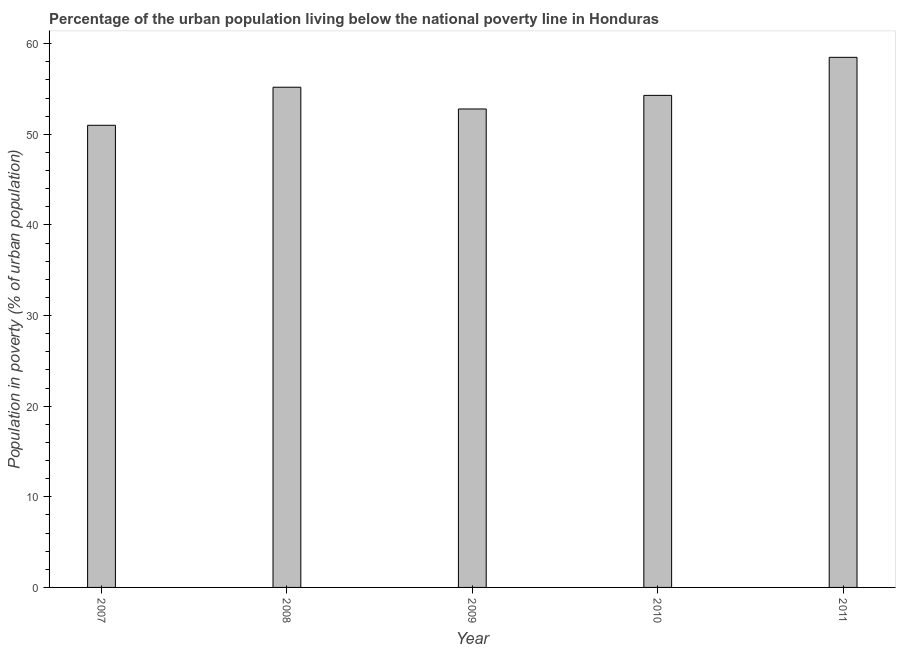Does the graph contain grids?
Ensure brevity in your answer.  No. What is the title of the graph?
Offer a terse response. Percentage of the urban population living below the national poverty line in Honduras. What is the label or title of the X-axis?
Your answer should be compact. Year. What is the label or title of the Y-axis?
Provide a short and direct response. Population in poverty (% of urban population). What is the percentage of urban population living below poverty line in 2007?
Keep it short and to the point. 51. Across all years, what is the maximum percentage of urban population living below poverty line?
Your response must be concise. 58.5. Across all years, what is the minimum percentage of urban population living below poverty line?
Keep it short and to the point. 51. What is the sum of the percentage of urban population living below poverty line?
Give a very brief answer. 271.8. What is the difference between the percentage of urban population living below poverty line in 2007 and 2010?
Your answer should be compact. -3.3. What is the average percentage of urban population living below poverty line per year?
Provide a succinct answer. 54.36. What is the median percentage of urban population living below poverty line?
Provide a succinct answer. 54.3. Do a majority of the years between 2008 and 2009 (inclusive) have percentage of urban population living below poverty line greater than 12 %?
Keep it short and to the point. Yes. What is the ratio of the percentage of urban population living below poverty line in 2010 to that in 2011?
Provide a succinct answer. 0.93. Is the difference between the percentage of urban population living below poverty line in 2008 and 2010 greater than the difference between any two years?
Provide a short and direct response. No. What is the difference between the highest and the second highest percentage of urban population living below poverty line?
Ensure brevity in your answer.  3.3. What is the difference between two consecutive major ticks on the Y-axis?
Give a very brief answer. 10. Are the values on the major ticks of Y-axis written in scientific E-notation?
Your answer should be very brief. No. What is the Population in poverty (% of urban population) in 2007?
Offer a terse response. 51. What is the Population in poverty (% of urban population) in 2008?
Make the answer very short. 55.2. What is the Population in poverty (% of urban population) of 2009?
Your response must be concise. 52.8. What is the Population in poverty (% of urban population) in 2010?
Provide a short and direct response. 54.3. What is the Population in poverty (% of urban population) in 2011?
Ensure brevity in your answer.  58.5. What is the difference between the Population in poverty (% of urban population) in 2007 and 2011?
Offer a very short reply. -7.5. What is the difference between the Population in poverty (% of urban population) in 2008 and 2010?
Your response must be concise. 0.9. What is the difference between the Population in poverty (% of urban population) in 2009 and 2010?
Your answer should be compact. -1.5. What is the ratio of the Population in poverty (% of urban population) in 2007 to that in 2008?
Ensure brevity in your answer.  0.92. What is the ratio of the Population in poverty (% of urban population) in 2007 to that in 2009?
Give a very brief answer. 0.97. What is the ratio of the Population in poverty (% of urban population) in 2007 to that in 2010?
Make the answer very short. 0.94. What is the ratio of the Population in poverty (% of urban population) in 2007 to that in 2011?
Ensure brevity in your answer.  0.87. What is the ratio of the Population in poverty (% of urban population) in 2008 to that in 2009?
Keep it short and to the point. 1.04. What is the ratio of the Population in poverty (% of urban population) in 2008 to that in 2010?
Your answer should be compact. 1.02. What is the ratio of the Population in poverty (% of urban population) in 2008 to that in 2011?
Give a very brief answer. 0.94. What is the ratio of the Population in poverty (% of urban population) in 2009 to that in 2011?
Provide a succinct answer. 0.9. What is the ratio of the Population in poverty (% of urban population) in 2010 to that in 2011?
Ensure brevity in your answer.  0.93. 